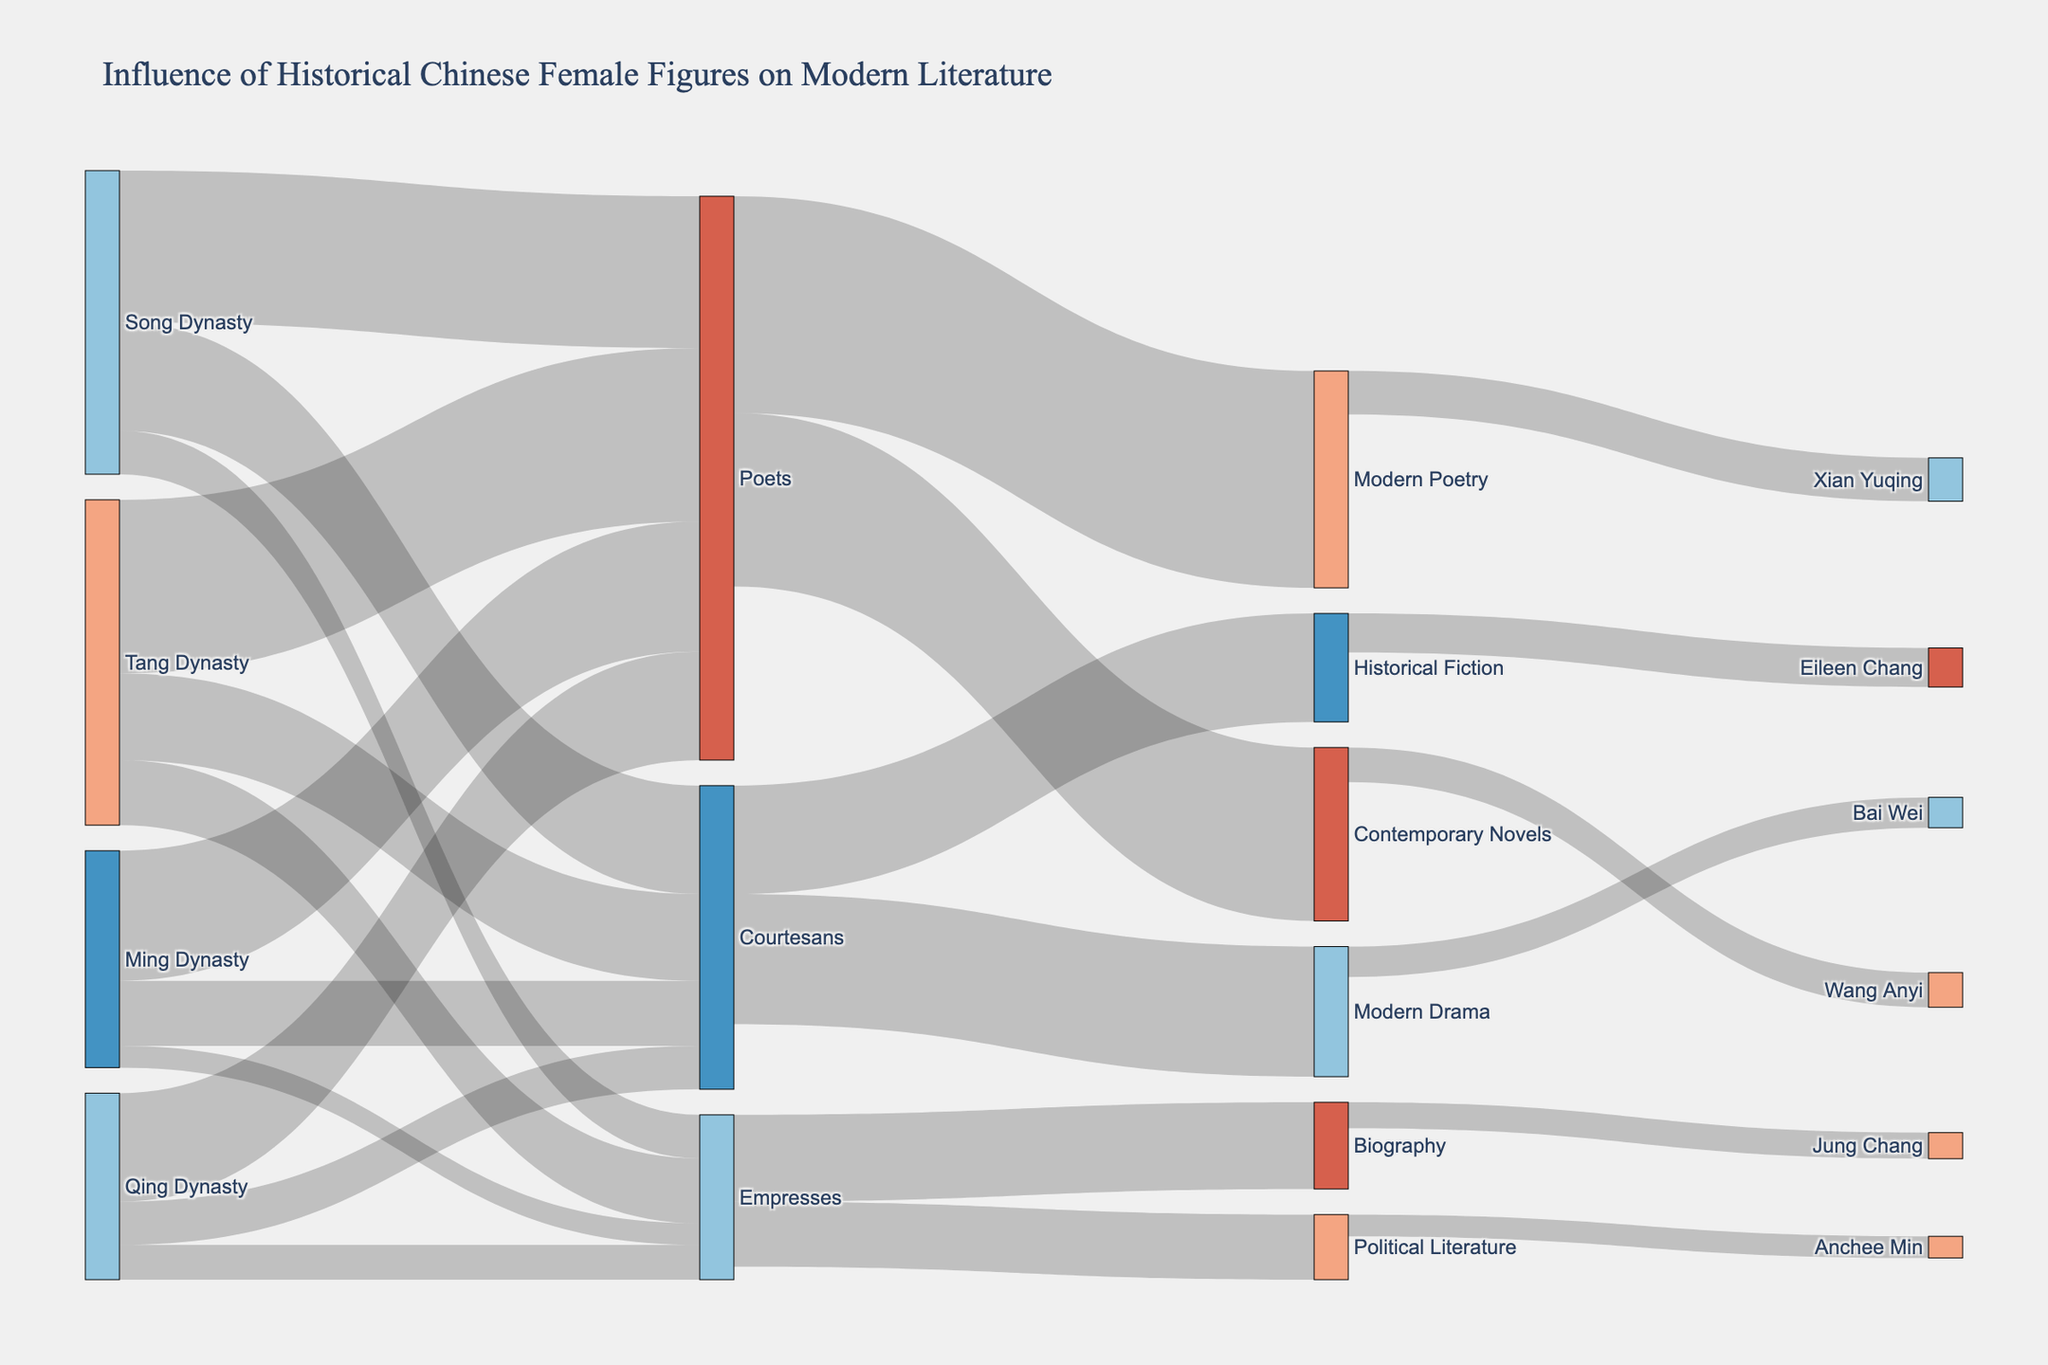what is the title of the Sankey Diagram? The title is usually prominently displayed at the top of the diagram. Here, it reads as "Influence of Historical Chinese Female Figures on Modern Literature"
Answer: Influence of Historical Chinese Female Figures on Modern Literature How many categories of roles are shown in the diagram? Observe the labels in the diagram that fall under the 'Roles' category. The roles listed are Poets, Courtesans, and Empresses, making it a total of three different roles.
Answer: Three Which historical period contributes the most to the influence on modern literature? By examining the 'Source' nodes related to each historical period and summing their respective values, we find that the Tang Dynasty's contributions (Poets: 40, Courtesans: 20, Empresses: 15) sum up to 75, which is the highest among all periods.
Answer: Tang Dynasty What is the total influence of Poets on Modern Poetry and Contemporary Novels? Identify the values for the links connecting 'Poets' to 'Modern Poetry' (50) and 'Contemporary Novels' (40). Summing these values gives 50 + 40 = 90.
Answer: 90 Compare the influence of Courtesans on Modern Drama versus Historical Fiction. Which one is greater? The links indicate 30 for 'Modern Drama' and 25 for 'Historical Fiction'. Thus, Courtesans influence Modern Drama (30) more than Historical Fiction (25).
Answer: Modern Drama How many female modern authors are influenced by the historical figures? Look for all the nodes that are names of authors at the far right of the diagram. There are six authors influenced by the historical figures listed.
Answer: Six Which modern female author is influenced the most by historical figures? Check the values connected to each modern female author. Xian Yuqing has the highest value of 10, indicating she is most influenced.
Answer: Xian Yuqing Which historical female figure role has the least influence on Political Literature? On the diagram, 'Empresses' connect to 'Political Literature' with a value of 15. Analyze the total influence on Political Literature, which points to the fact that Empresses have the link to Political Literature, compared to no other role directly contributing to Political Literature.
Answer: Empresses What is the combined influence of the Song Dynasty and Qing Dynasty on Poets? Find the values for the Song Dynasty to Poets (35) and Qing Dynasty to Poets (25). Adding these values gives 35 + 25 = 60.
Answer: 60 Which type of modern literature has the most influence from historical Courtesans? Compare the values connected to 'Modern Drama' (30) and 'Historical Fiction' (25). Modern Drama has the higher value, indicating it has the most influence from Courtesans.
Answer: Modern Drama 